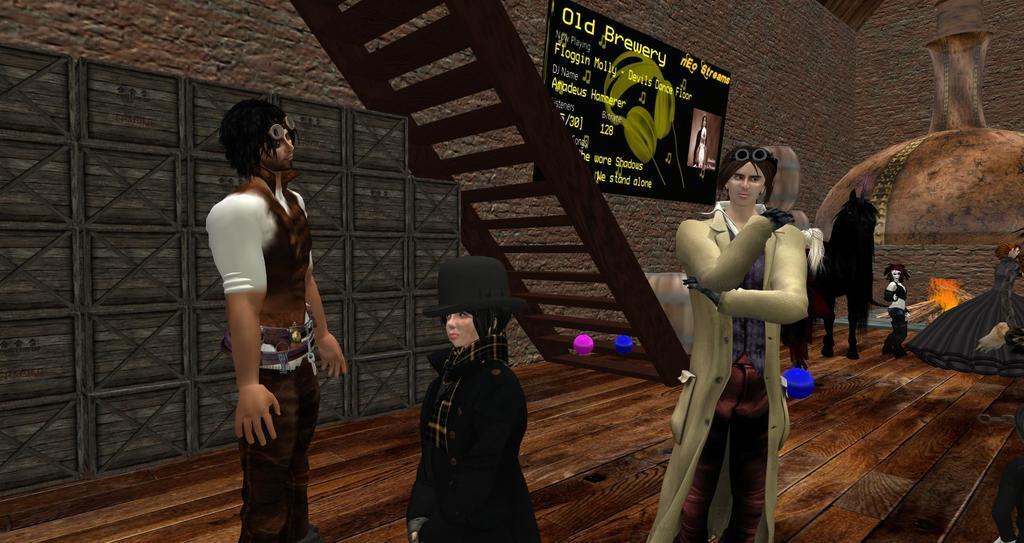Please provide a concise description of this image. This picture describes about animation. 